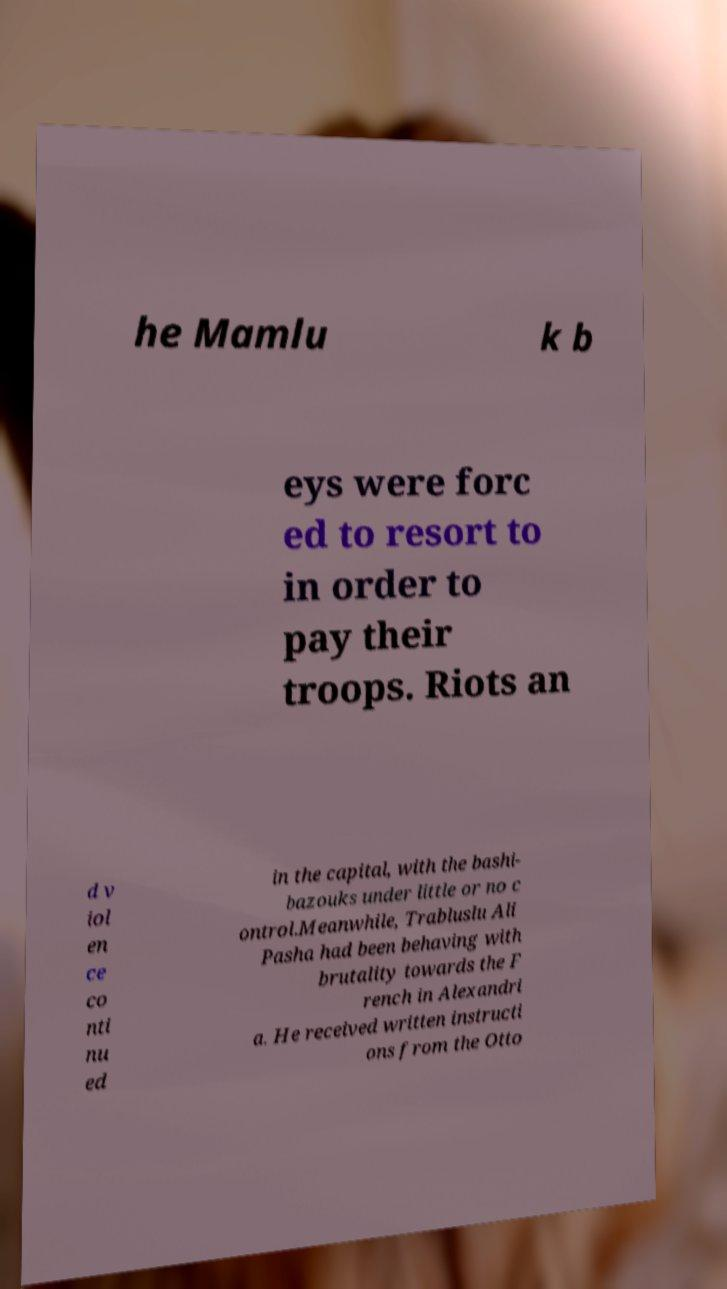Could you assist in decoding the text presented in this image and type it out clearly? he Mamlu k b eys were forc ed to resort to in order to pay their troops. Riots an d v iol en ce co nti nu ed in the capital, with the bashi- bazouks under little or no c ontrol.Meanwhile, Trabluslu Ali Pasha had been behaving with brutality towards the F rench in Alexandri a. He received written instructi ons from the Otto 